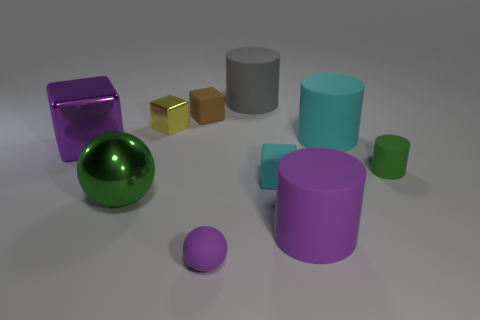What could be the purpose of this image? This image might serve several purposes. It could be a render to demonstrate a 3D artist's skill in creating and arranging basic geometric shapes with various materials and textures. Alternatively, it may be used in educational contexts to teach about shapes, volume, and geometry, or in design and art to explore color theory and composition. 